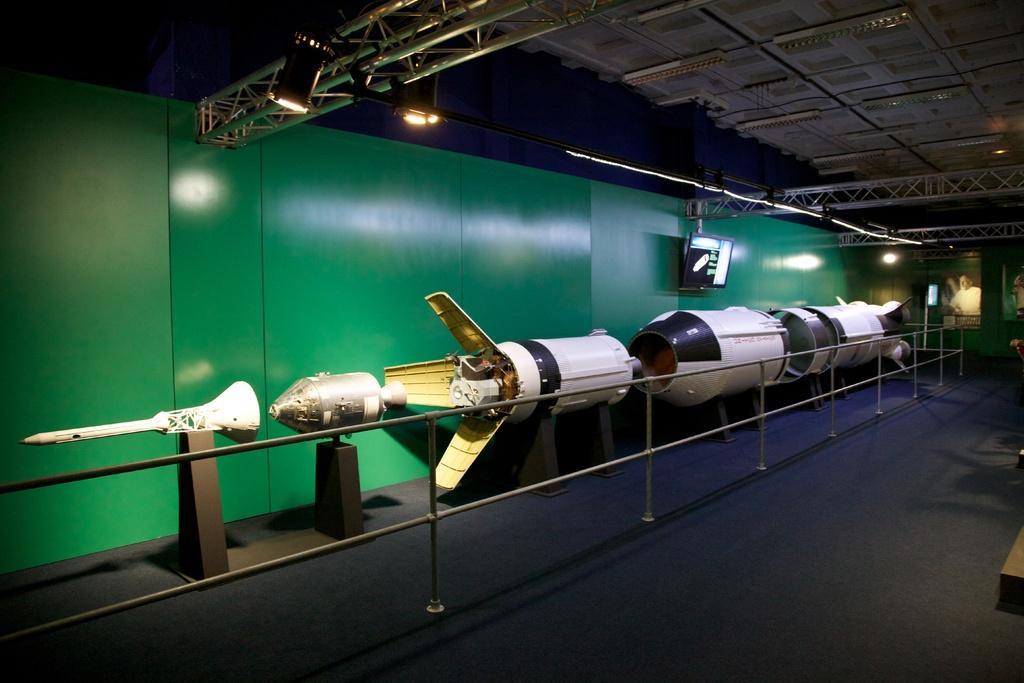Describe this image in one or two sentences. In this image I can see the parts of the rocket which are white, black and brown in color on the other side of the railing and I can see the wall which is green in color, few metal rods, few lights and the blue colored surface. In the background I can see the ceiling, few lights to the ceiling, the green colored wall and few photo frames attached to the wall. 